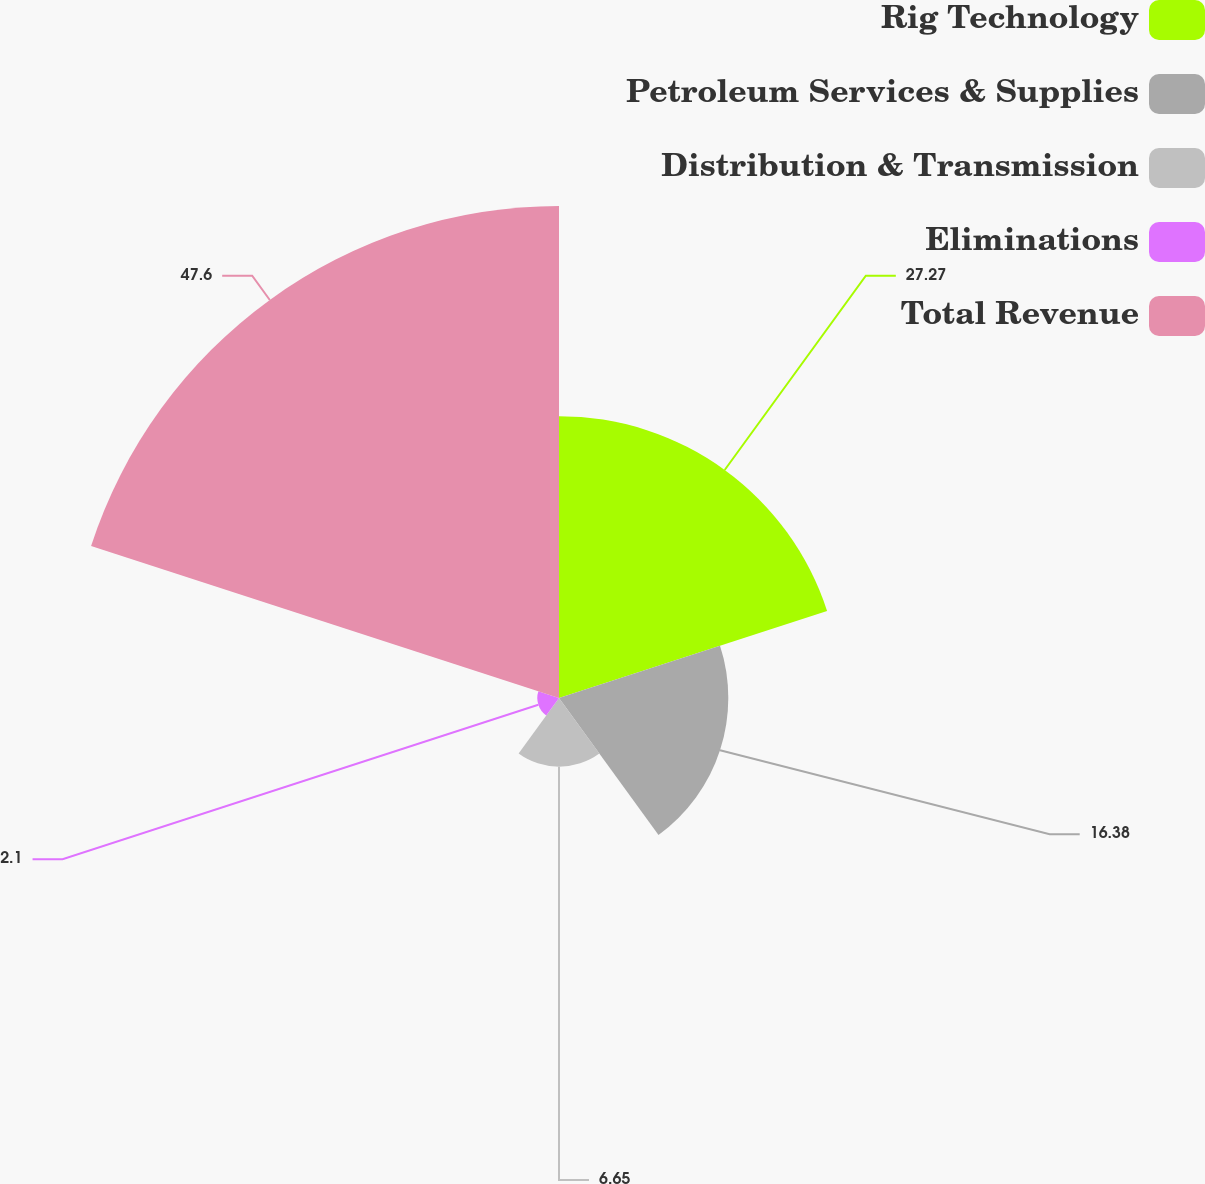Convert chart to OTSL. <chart><loc_0><loc_0><loc_500><loc_500><pie_chart><fcel>Rig Technology<fcel>Petroleum Services & Supplies<fcel>Distribution & Transmission<fcel>Eliminations<fcel>Total Revenue<nl><fcel>27.27%<fcel>16.38%<fcel>6.65%<fcel>2.1%<fcel>47.6%<nl></chart> 